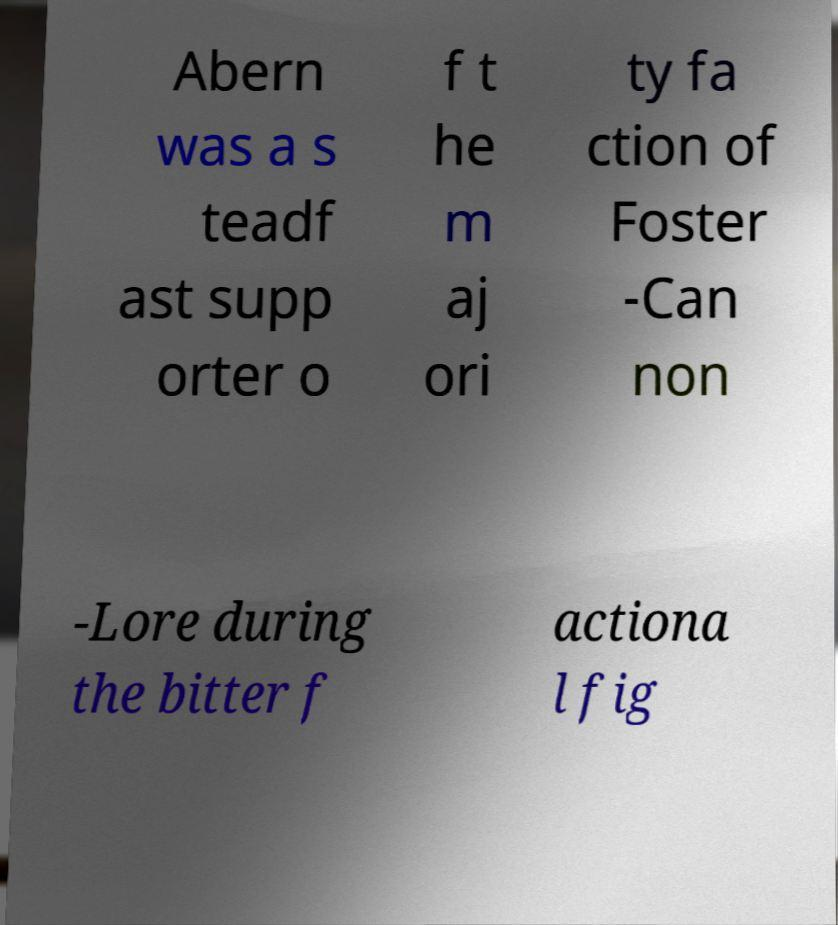Please read and relay the text visible in this image. What does it say? Abern was a s teadf ast supp orter o f t he m aj ori ty fa ction of Foster -Can non -Lore during the bitter f actiona l fig 